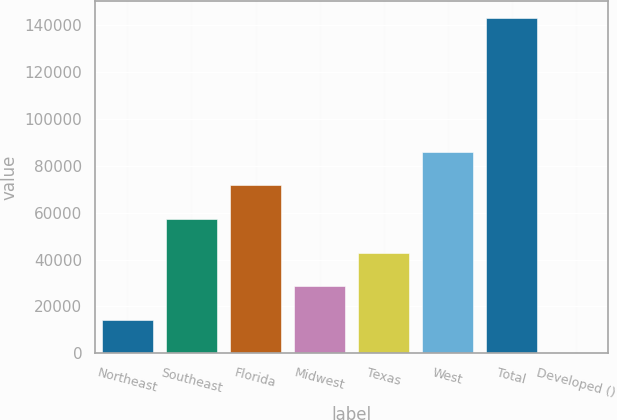Convert chart to OTSL. <chart><loc_0><loc_0><loc_500><loc_500><bar_chart><fcel>Northeast<fcel>Southeast<fcel>Florida<fcel>Midwest<fcel>Texas<fcel>West<fcel>Total<fcel>Developed ()<nl><fcel>14351<fcel>57320<fcel>71643<fcel>28674<fcel>42997<fcel>85966<fcel>143258<fcel>28<nl></chart> 